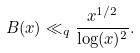<formula> <loc_0><loc_0><loc_500><loc_500>B ( x ) \ll _ { q } \frac { x ^ { 1 / 2 } } { \log ( x ) ^ { 2 } } .</formula> 